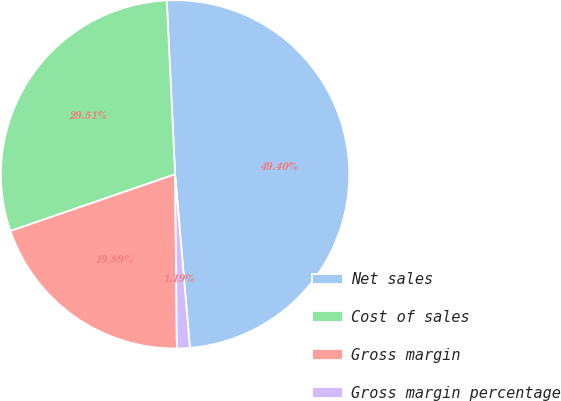Convert chart. <chart><loc_0><loc_0><loc_500><loc_500><pie_chart><fcel>Net sales<fcel>Cost of sales<fcel>Gross margin<fcel>Gross margin percentage<nl><fcel>49.4%<fcel>29.51%<fcel>19.89%<fcel>1.19%<nl></chart> 